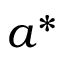Convert formula to latex. <formula><loc_0><loc_0><loc_500><loc_500>a ^ { * }</formula> 